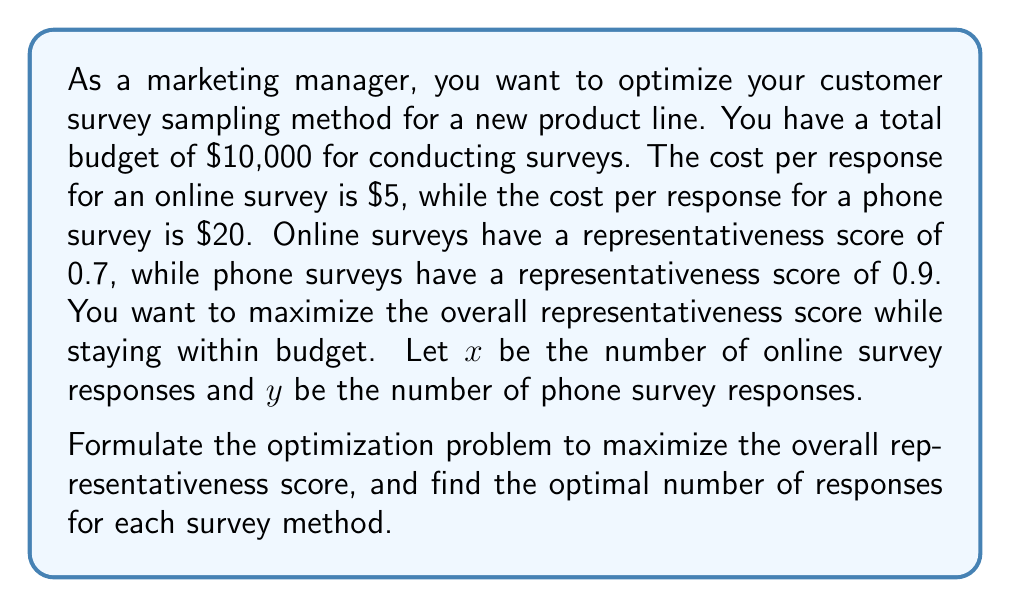Can you solve this math problem? To solve this optimization problem, we'll follow these steps:

1. Define the objective function:
   The overall representativeness score is a weighted average of the two methods:
   $$f(x,y) = \frac{0.7x + 0.9y}{x + y}$$

2. Define the constraints:
   Budget constraint: $5x + 20y \leq 10000$
   Non-negativity: $x \geq 0, y \geq 0$

3. Set up the optimization problem:
   $$\text{Maximize } f(x,y) = \frac{0.7x + 0.9y}{x + y}$$
   $$\text{Subject to: } 5x + 20y \leq 10000$$
   $$x \geq 0, y \geq 0$$

4. Solve using the method of Lagrange multipliers:
   Let $g(x,y) = 5x + 20y - 10000$
   
   Form the Lagrangian:
   $$L(x,y,\lambda) = \frac{0.7x + 0.9y}{x + y} - \lambda(5x + 20y - 10000)$$

5. Take partial derivatives and set them to zero:
   $$\frac{\partial L}{\partial x} = \frac{0.7(x+y) - (0.7x + 0.9y)}{(x+y)^2} - 5\lambda = 0$$
   $$\frac{\partial L}{\partial y} = \frac{0.9(x+y) - (0.7x + 0.9y)}{(x+y)^2} - 20\lambda = 0$$
   $$\frac{\partial L}{\partial \lambda} = 5x + 20y - 10000 = 0$$

6. Solving these equations:
   From the first two equations, we get:
   $$\frac{0.2y}{(x+y)^2} = 15\lambda$$
   
   This implies that $y = 3x$ (since the cost ratio is 1:4)

7. Substitute into the budget constraint:
   $$5x + 20(3x) = 10000$$
   $$65x = 10000$$
   $$x = \frac{10000}{65} \approx 153.85$$

8. Round down to stay within budget:
   $x = 153$ (online survey responses)
   $y = 3x = 459$ (phone survey responses)

9. Verify the budget constraint:
   $5(153) + 20(459) = 765 + 9180 = 9945 \leq 10000$

10. Calculate the overall representativeness score:
    $$f(153, 459) = \frac{0.7(153) + 0.9(459)}{153 + 459} \approx 0.85$$
Answer: The optimal solution is to conduct 153 online surveys and 459 phone surveys, resulting in an overall representativeness score of approximately 0.85. 